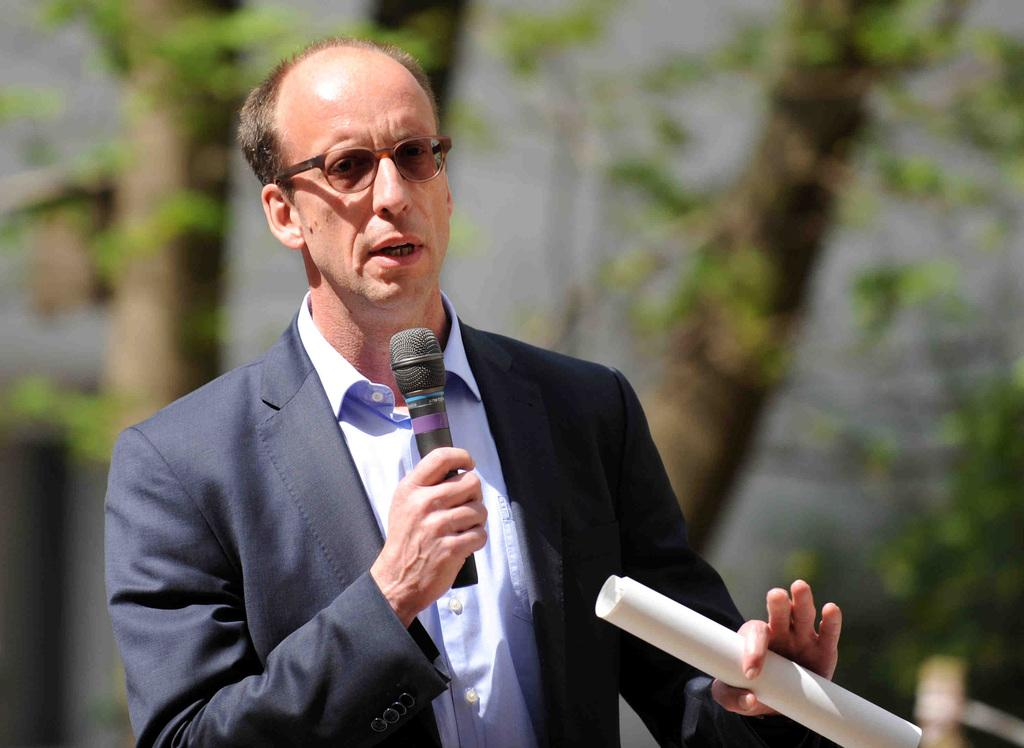What is the main subject of subject of the image? The main subject of the image is a man. What is the man wearing in the image? The man is wearing a suit and a white shirt. What is the man holding in his hands in the image? The man is holding a microphone in one hand and some papers in the other hand. What accessory is the man wearing in the image? The man is wearing spectacles. What can be seen in the background of the image? There are trees visible in the background of the image. How many cows are visible in the image? There are no cows present in the image; it features a man holding a microphone and papers. What type of news is being reported by the man in the image? The image does not provide any information about the news being reported by the man, as it only shows him holding a microphone and papers. 